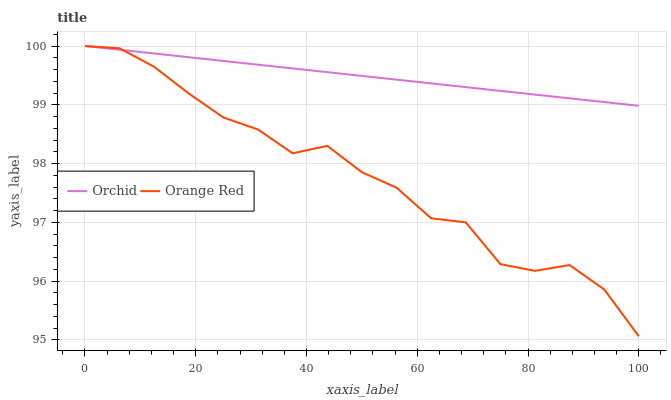Does Orange Red have the minimum area under the curve?
Answer yes or no. Yes. Does Orchid have the maximum area under the curve?
Answer yes or no. Yes. Does Orchid have the minimum area under the curve?
Answer yes or no. No. Is Orchid the smoothest?
Answer yes or no. Yes. Is Orange Red the roughest?
Answer yes or no. Yes. Is Orchid the roughest?
Answer yes or no. No. Does Orange Red have the lowest value?
Answer yes or no. Yes. Does Orchid have the lowest value?
Answer yes or no. No. Does Orchid have the highest value?
Answer yes or no. Yes. Does Orange Red intersect Orchid?
Answer yes or no. Yes. Is Orange Red less than Orchid?
Answer yes or no. No. Is Orange Red greater than Orchid?
Answer yes or no. No. 